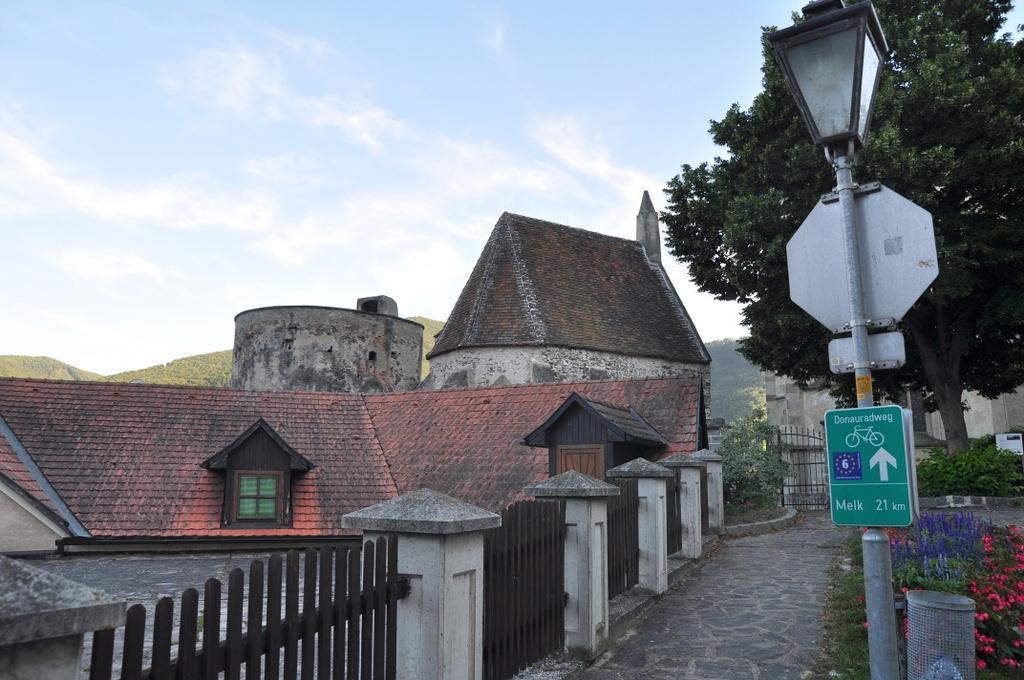Can you describe this image briefly? In this image we can see the houses, hills, trees, plants, trash bin and also the path. We can also see the gate and also the fence. In the background we can see the sky with some clouds. 